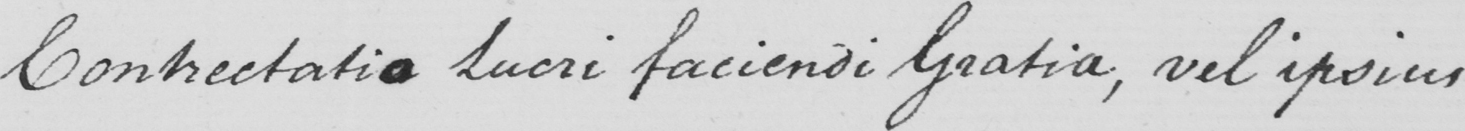Can you tell me what this handwritten text says? Contrectatio Lucri faciendi Gratia , vel ipsius 